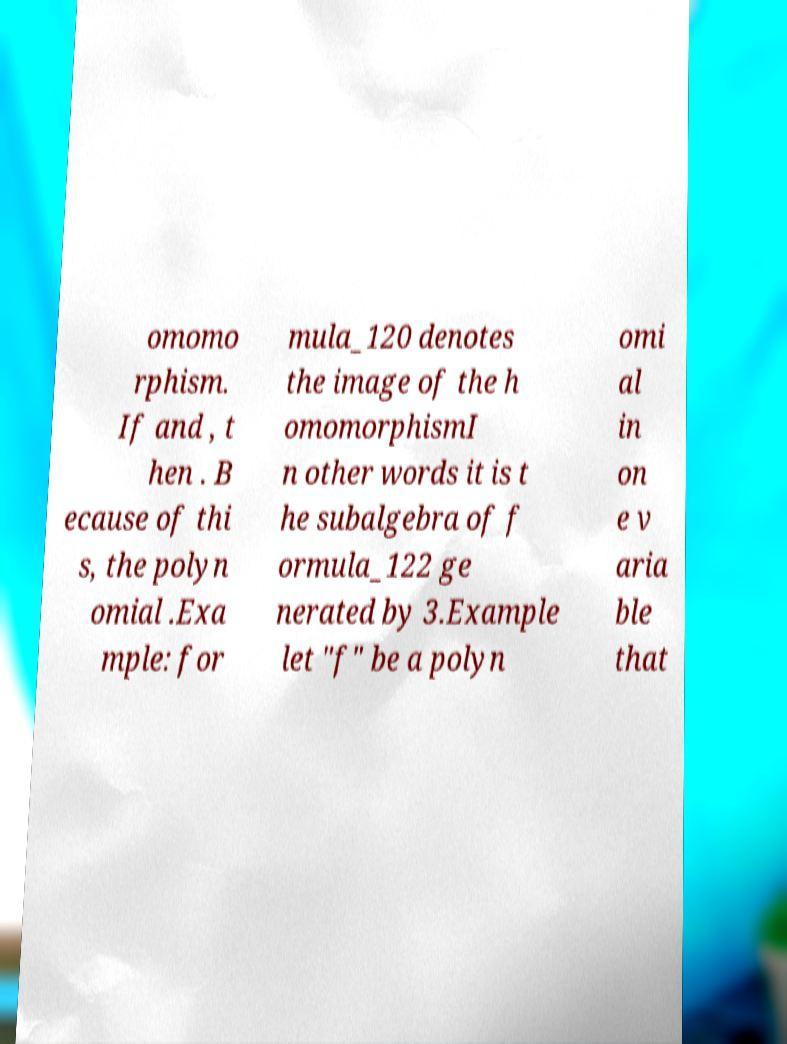Please identify and transcribe the text found in this image. omomo rphism. If and , t hen . B ecause of thi s, the polyn omial .Exa mple: for mula_120 denotes the image of the h omomorphismI n other words it is t he subalgebra of f ormula_122 ge nerated by 3.Example let "f" be a polyn omi al in on e v aria ble that 